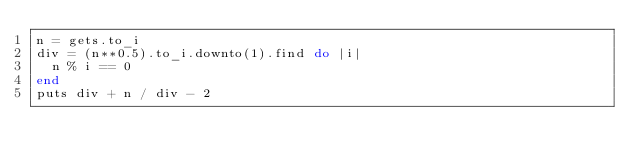<code> <loc_0><loc_0><loc_500><loc_500><_Ruby_>n = gets.to_i
div = (n**0.5).to_i.downto(1).find do |i|
  n % i == 0
end
puts div + n / div - 2
</code> 